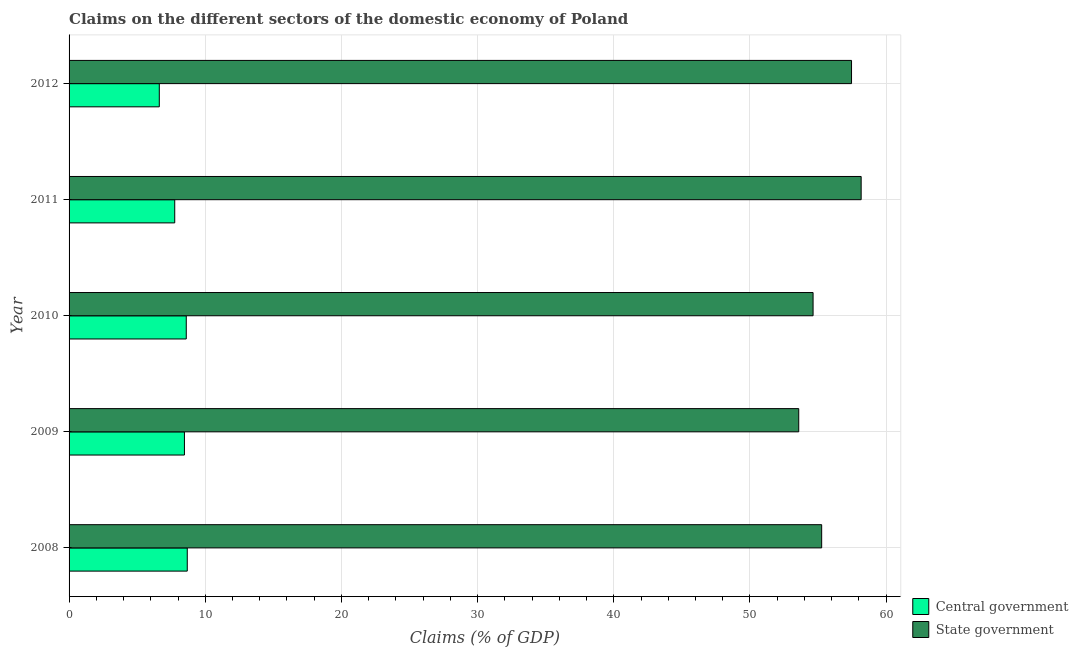How many groups of bars are there?
Make the answer very short. 5. Are the number of bars on each tick of the Y-axis equal?
Make the answer very short. Yes. What is the claims on state government in 2011?
Give a very brief answer. 58.16. Across all years, what is the maximum claims on central government?
Offer a terse response. 8.68. Across all years, what is the minimum claims on central government?
Offer a very short reply. 6.63. In which year was the claims on central government maximum?
Your answer should be compact. 2008. What is the total claims on central government in the graph?
Provide a short and direct response. 40.14. What is the difference between the claims on central government in 2008 and that in 2012?
Offer a terse response. 2.05. What is the difference between the claims on central government in 2012 and the claims on state government in 2010?
Give a very brief answer. -48.01. What is the average claims on state government per year?
Ensure brevity in your answer.  55.82. In the year 2012, what is the difference between the claims on state government and claims on central government?
Offer a very short reply. 50.83. In how many years, is the claims on central government greater than 48 %?
Your answer should be compact. 0. Is the difference between the claims on central government in 2008 and 2012 greater than the difference between the claims on state government in 2008 and 2012?
Offer a terse response. Yes. What is the difference between the highest and the second highest claims on central government?
Your answer should be very brief. 0.07. What is the difference between the highest and the lowest claims on state government?
Offer a terse response. 4.58. In how many years, is the claims on state government greater than the average claims on state government taken over all years?
Give a very brief answer. 2. What does the 1st bar from the top in 2009 represents?
Provide a succinct answer. State government. What does the 2nd bar from the bottom in 2009 represents?
Provide a short and direct response. State government. How many bars are there?
Offer a very short reply. 10. How many years are there in the graph?
Your answer should be very brief. 5. What is the difference between two consecutive major ticks on the X-axis?
Offer a very short reply. 10. Are the values on the major ticks of X-axis written in scientific E-notation?
Give a very brief answer. No. Does the graph contain grids?
Your response must be concise. Yes. How are the legend labels stacked?
Your answer should be very brief. Vertical. What is the title of the graph?
Your response must be concise. Claims on the different sectors of the domestic economy of Poland. Does "Central government" appear as one of the legend labels in the graph?
Your response must be concise. Yes. What is the label or title of the X-axis?
Your answer should be very brief. Claims (% of GDP). What is the label or title of the Y-axis?
Provide a succinct answer. Year. What is the Claims (% of GDP) of Central government in 2008?
Give a very brief answer. 8.68. What is the Claims (% of GDP) of State government in 2008?
Make the answer very short. 55.27. What is the Claims (% of GDP) of Central government in 2009?
Provide a short and direct response. 8.47. What is the Claims (% of GDP) of State government in 2009?
Offer a terse response. 53.58. What is the Claims (% of GDP) of Central government in 2010?
Make the answer very short. 8.61. What is the Claims (% of GDP) in State government in 2010?
Ensure brevity in your answer.  54.64. What is the Claims (% of GDP) of Central government in 2011?
Keep it short and to the point. 7.76. What is the Claims (% of GDP) in State government in 2011?
Provide a succinct answer. 58.16. What is the Claims (% of GDP) in Central government in 2012?
Give a very brief answer. 6.63. What is the Claims (% of GDP) in State government in 2012?
Provide a short and direct response. 57.46. Across all years, what is the maximum Claims (% of GDP) in Central government?
Make the answer very short. 8.68. Across all years, what is the maximum Claims (% of GDP) of State government?
Your answer should be compact. 58.16. Across all years, what is the minimum Claims (% of GDP) of Central government?
Ensure brevity in your answer.  6.63. Across all years, what is the minimum Claims (% of GDP) of State government?
Make the answer very short. 53.58. What is the total Claims (% of GDP) of Central government in the graph?
Provide a succinct answer. 40.14. What is the total Claims (% of GDP) in State government in the graph?
Your response must be concise. 279.1. What is the difference between the Claims (% of GDP) of Central government in 2008 and that in 2009?
Your response must be concise. 0.21. What is the difference between the Claims (% of GDP) in State government in 2008 and that in 2009?
Keep it short and to the point. 1.68. What is the difference between the Claims (% of GDP) in Central government in 2008 and that in 2010?
Provide a short and direct response. 0.07. What is the difference between the Claims (% of GDP) of State government in 2008 and that in 2010?
Keep it short and to the point. 0.63. What is the difference between the Claims (% of GDP) of Central government in 2008 and that in 2011?
Your answer should be compact. 0.92. What is the difference between the Claims (% of GDP) of State government in 2008 and that in 2011?
Offer a very short reply. -2.9. What is the difference between the Claims (% of GDP) in Central government in 2008 and that in 2012?
Your response must be concise. 2.05. What is the difference between the Claims (% of GDP) in State government in 2008 and that in 2012?
Your answer should be very brief. -2.19. What is the difference between the Claims (% of GDP) of Central government in 2009 and that in 2010?
Make the answer very short. -0.13. What is the difference between the Claims (% of GDP) in State government in 2009 and that in 2010?
Provide a succinct answer. -1.05. What is the difference between the Claims (% of GDP) in Central government in 2009 and that in 2011?
Provide a succinct answer. 0.71. What is the difference between the Claims (% of GDP) in State government in 2009 and that in 2011?
Your answer should be very brief. -4.58. What is the difference between the Claims (% of GDP) in Central government in 2009 and that in 2012?
Offer a terse response. 1.85. What is the difference between the Claims (% of GDP) of State government in 2009 and that in 2012?
Your answer should be compact. -3.88. What is the difference between the Claims (% of GDP) of Central government in 2010 and that in 2011?
Offer a terse response. 0.85. What is the difference between the Claims (% of GDP) in State government in 2010 and that in 2011?
Ensure brevity in your answer.  -3.53. What is the difference between the Claims (% of GDP) in Central government in 2010 and that in 2012?
Provide a succinct answer. 1.98. What is the difference between the Claims (% of GDP) in State government in 2010 and that in 2012?
Ensure brevity in your answer.  -2.82. What is the difference between the Claims (% of GDP) of Central government in 2011 and that in 2012?
Your answer should be compact. 1.13. What is the difference between the Claims (% of GDP) in State government in 2011 and that in 2012?
Provide a short and direct response. 0.71. What is the difference between the Claims (% of GDP) of Central government in 2008 and the Claims (% of GDP) of State government in 2009?
Provide a short and direct response. -44.9. What is the difference between the Claims (% of GDP) in Central government in 2008 and the Claims (% of GDP) in State government in 2010?
Provide a short and direct response. -45.96. What is the difference between the Claims (% of GDP) of Central government in 2008 and the Claims (% of GDP) of State government in 2011?
Your answer should be compact. -49.49. What is the difference between the Claims (% of GDP) in Central government in 2008 and the Claims (% of GDP) in State government in 2012?
Your response must be concise. -48.78. What is the difference between the Claims (% of GDP) in Central government in 2009 and the Claims (% of GDP) in State government in 2010?
Your response must be concise. -46.16. What is the difference between the Claims (% of GDP) of Central government in 2009 and the Claims (% of GDP) of State government in 2011?
Make the answer very short. -49.69. What is the difference between the Claims (% of GDP) of Central government in 2009 and the Claims (% of GDP) of State government in 2012?
Keep it short and to the point. -48.99. What is the difference between the Claims (% of GDP) in Central government in 2010 and the Claims (% of GDP) in State government in 2011?
Provide a short and direct response. -49.56. What is the difference between the Claims (% of GDP) in Central government in 2010 and the Claims (% of GDP) in State government in 2012?
Provide a succinct answer. -48.85. What is the difference between the Claims (% of GDP) of Central government in 2011 and the Claims (% of GDP) of State government in 2012?
Give a very brief answer. -49.7. What is the average Claims (% of GDP) of Central government per year?
Ensure brevity in your answer.  8.03. What is the average Claims (% of GDP) of State government per year?
Ensure brevity in your answer.  55.82. In the year 2008, what is the difference between the Claims (% of GDP) of Central government and Claims (% of GDP) of State government?
Your answer should be compact. -46.59. In the year 2009, what is the difference between the Claims (% of GDP) in Central government and Claims (% of GDP) in State government?
Keep it short and to the point. -45.11. In the year 2010, what is the difference between the Claims (% of GDP) in Central government and Claims (% of GDP) in State government?
Your answer should be very brief. -46.03. In the year 2011, what is the difference between the Claims (% of GDP) in Central government and Claims (% of GDP) in State government?
Provide a short and direct response. -50.41. In the year 2012, what is the difference between the Claims (% of GDP) of Central government and Claims (% of GDP) of State government?
Your response must be concise. -50.83. What is the ratio of the Claims (% of GDP) of Central government in 2008 to that in 2009?
Ensure brevity in your answer.  1.02. What is the ratio of the Claims (% of GDP) in State government in 2008 to that in 2009?
Keep it short and to the point. 1.03. What is the ratio of the Claims (% of GDP) of Central government in 2008 to that in 2010?
Keep it short and to the point. 1.01. What is the ratio of the Claims (% of GDP) in State government in 2008 to that in 2010?
Your answer should be very brief. 1.01. What is the ratio of the Claims (% of GDP) of Central government in 2008 to that in 2011?
Provide a short and direct response. 1.12. What is the ratio of the Claims (% of GDP) of State government in 2008 to that in 2011?
Ensure brevity in your answer.  0.95. What is the ratio of the Claims (% of GDP) of Central government in 2008 to that in 2012?
Offer a terse response. 1.31. What is the ratio of the Claims (% of GDP) in State government in 2008 to that in 2012?
Provide a short and direct response. 0.96. What is the ratio of the Claims (% of GDP) of Central government in 2009 to that in 2010?
Make the answer very short. 0.98. What is the ratio of the Claims (% of GDP) of State government in 2009 to that in 2010?
Make the answer very short. 0.98. What is the ratio of the Claims (% of GDP) in Central government in 2009 to that in 2011?
Your answer should be very brief. 1.09. What is the ratio of the Claims (% of GDP) of State government in 2009 to that in 2011?
Give a very brief answer. 0.92. What is the ratio of the Claims (% of GDP) in Central government in 2009 to that in 2012?
Provide a short and direct response. 1.28. What is the ratio of the Claims (% of GDP) in State government in 2009 to that in 2012?
Provide a succinct answer. 0.93. What is the ratio of the Claims (% of GDP) of Central government in 2010 to that in 2011?
Offer a very short reply. 1.11. What is the ratio of the Claims (% of GDP) in State government in 2010 to that in 2011?
Give a very brief answer. 0.94. What is the ratio of the Claims (% of GDP) in Central government in 2010 to that in 2012?
Make the answer very short. 1.3. What is the ratio of the Claims (% of GDP) of State government in 2010 to that in 2012?
Ensure brevity in your answer.  0.95. What is the ratio of the Claims (% of GDP) of Central government in 2011 to that in 2012?
Keep it short and to the point. 1.17. What is the ratio of the Claims (% of GDP) of State government in 2011 to that in 2012?
Your answer should be compact. 1.01. What is the difference between the highest and the second highest Claims (% of GDP) in Central government?
Ensure brevity in your answer.  0.07. What is the difference between the highest and the second highest Claims (% of GDP) in State government?
Ensure brevity in your answer.  0.71. What is the difference between the highest and the lowest Claims (% of GDP) in Central government?
Offer a terse response. 2.05. What is the difference between the highest and the lowest Claims (% of GDP) in State government?
Your answer should be very brief. 4.58. 